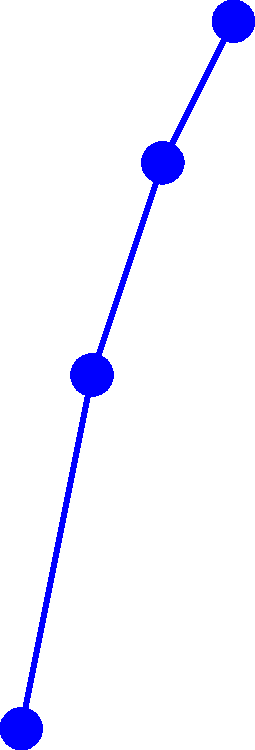Based on the graph showing the efficiency of different gear tooth profiles under varying loads, which profile demonstrates the highest overall efficiency across the load range? How might this information help alleviate concerns about equipment performance during presentations? Let's analyze the graph step-by-step:

1. The graph shows three different gear tooth profiles: Involute (blue), Cycloidal (red), and Straight (green).
2. The x-axis represents the load in kN, ranging from 0 to 3 kN.
3. The y-axis represents the efficiency in percentage, ranging from 65% to 95%.
4. We need to compare the efficiency of each profile across the entire load range:

   At 0 kN:
   - Involute: 80%
   - Cycloidal: 75%
   - Straight: 70%

   At 1 kN:
   - Involute: 85%
   - Cycloidal: 82%
   - Straight: 78%

   At 2 kN:
   - Involute: 88%
   - Cycloidal: 86%
   - Straight: 83%

   At 3 kN:
   - Involute: 90%
   - Cycloidal: 89%
   - Straight: 87%

5. The Involute profile (blue line) consistently shows the highest efficiency across all load points.

6. This information can help alleviate concerns about equipment performance during presentations by:
   - Demonstrating a clear understanding of gear efficiency
   - Showing confidence in choosing the most efficient gear tooth profile
   - Providing data-driven evidence to support design decisions
   - Illustrating how proper gear selection can optimize power transmission
Answer: Involute profile; it provides data-driven confidence in gear selection and performance. 